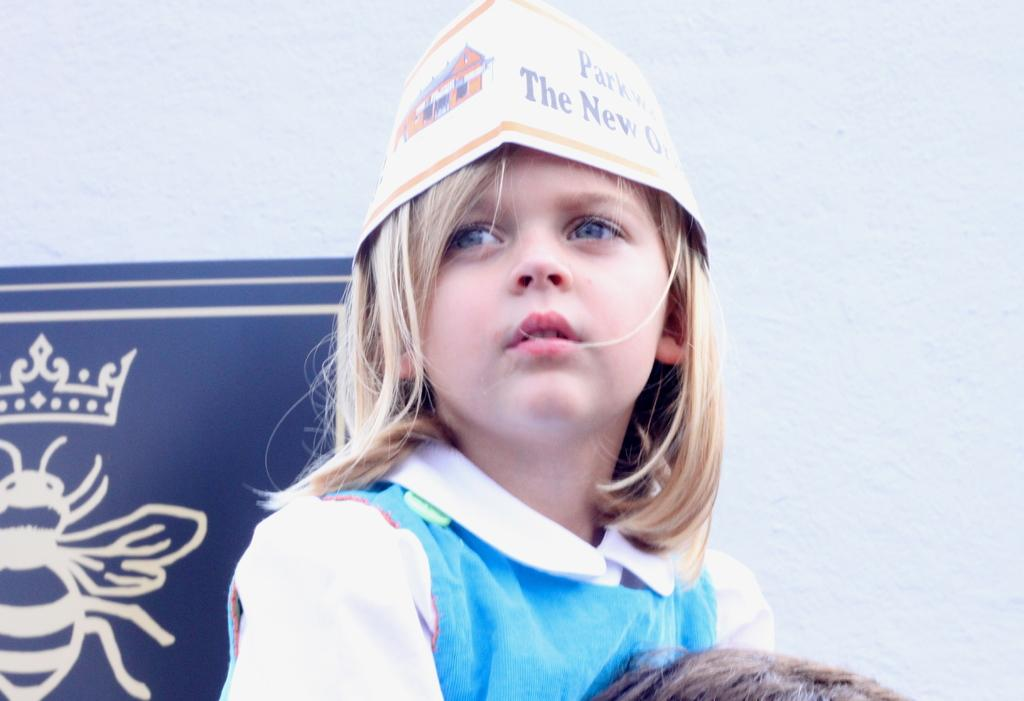Who is the main subject in the image? There is a girl in the center of the image. What is the girl wearing on her head? The girl is wearing a cap. What can be seen at the bottom of the image? There is a person's head at the bottom of the image. What is visible in the background of the image? There is a board and a wall in the background of the image. What is the girl's opinion on humor in the image? There is no indication of the girl's opinion on humor in the image. Can you hear thunder in the image? There is no sound or audible element in the image, so it is impossible to hear thunder. 